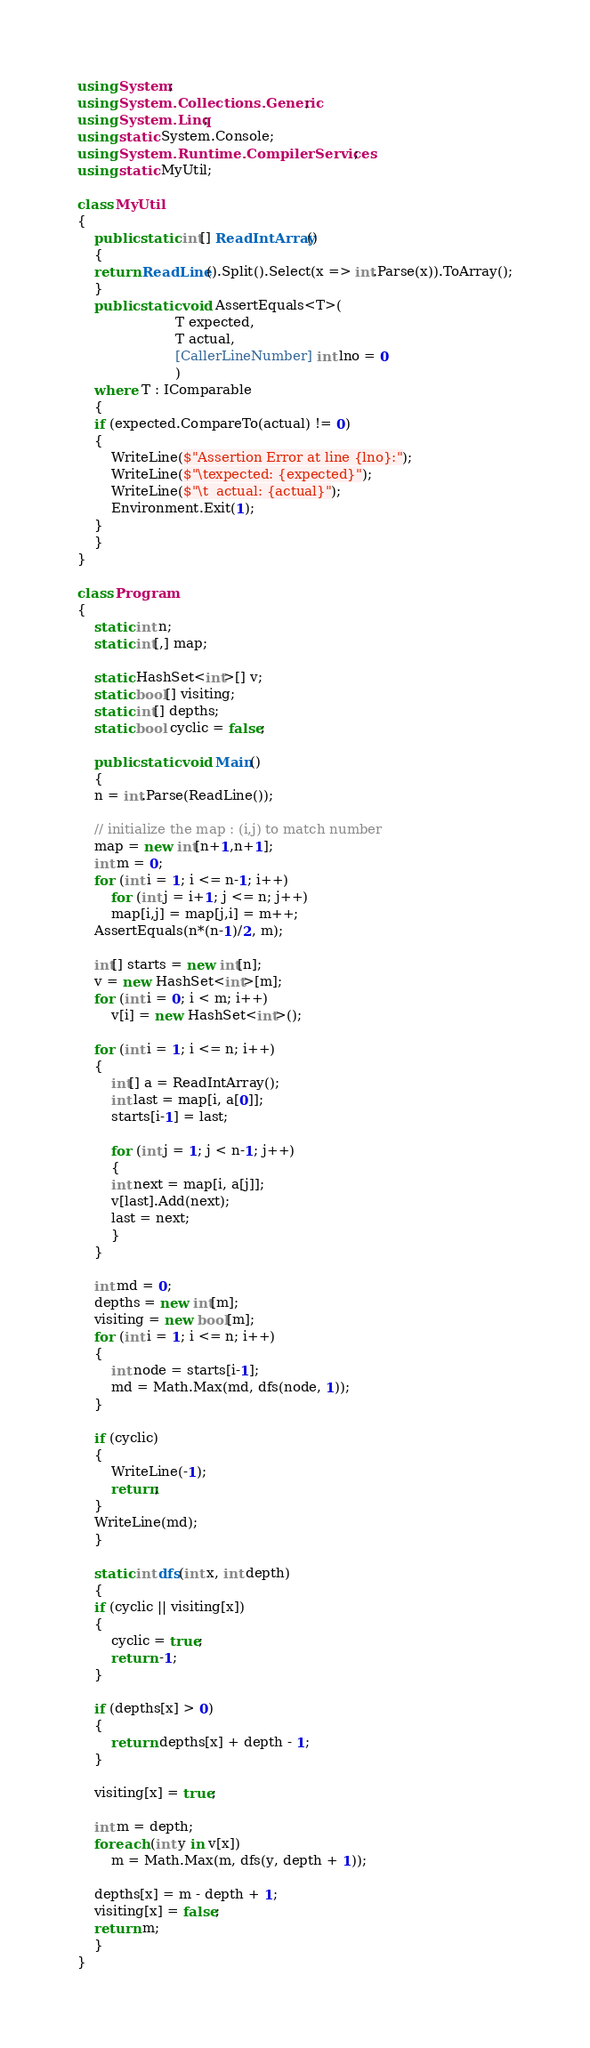Convert code to text. <code><loc_0><loc_0><loc_500><loc_500><_C#_>using System;
using System.Collections.Generic;
using System.Linq;
using static System.Console;
using System.Runtime.CompilerServices;
using static MyUtil;

class MyUtil
{
    public static int[] ReadIntArray()
    {
	return ReadLine().Split().Select(x => int.Parse(x)).ToArray();
    }
    public static void AssertEquals<T>(
				       T expected,
				       T actual,
				       [CallerLineNumber] int lno = 0
				       )
	where T : IComparable
    {
	if (expected.CompareTo(actual) != 0)
	{
	    WriteLine($"Assertion Error at line {lno}:");
	    WriteLine($"\texpected: {expected}");
	    WriteLine($"\t  actual: {actual}");
	    Environment.Exit(1);
	}
    }
}

class Program
{
    static int n;
    static int[,] map;

    static HashSet<int>[] v;
    static bool[] visiting;
    static int[] depths;
    static bool cyclic = false;
    
    public static void Main()
    {
	n = int.Parse(ReadLine());

	// initialize the map : (i,j) to match number
	map = new int[n+1,n+1];
	int m = 0;
	for (int i = 1; i <= n-1; i++)
	    for (int j = i+1; j <= n; j++)
		map[i,j] = map[j,i] = m++;
	AssertEquals(n*(n-1)/2, m);

	int[] starts = new int[n];
	v = new HashSet<int>[m];
	for (int i = 0; i < m; i++)
	    v[i] = new HashSet<int>();
	
	for (int i = 1; i <= n; i++)
	{
	    int[] a = ReadIntArray();
	    int last = map[i, a[0]];
	    starts[i-1] = last;

	    for (int j = 1; j < n-1; j++)
	    {
		int next = map[i, a[j]];
		v[last].Add(next);
		last = next;
	    }
	}

	int md = 0;
	depths = new int[m];
	visiting = new bool[m];
	for (int i = 1; i <= n; i++)
	{
	    int node = starts[i-1];
	    md = Math.Max(md, dfs(node, 1));
	}

	if (cyclic)
	{
	    WriteLine(-1);
	    return;
	}
	WriteLine(md);
    }

    static int dfs(int x, int depth)
    {
	if (cyclic || visiting[x])
	{
	    cyclic = true;
	    return -1;
	}
	
	if (depths[x] > 0)
	{
	    return depths[x] + depth - 1;
	}
	
	visiting[x] = true;

	int m = depth;
	foreach (int y in v[x])
	    m = Math.Max(m, dfs(y, depth + 1));

	depths[x] = m - depth + 1;
	visiting[x] = false;
	return m;
    }
}
</code> 